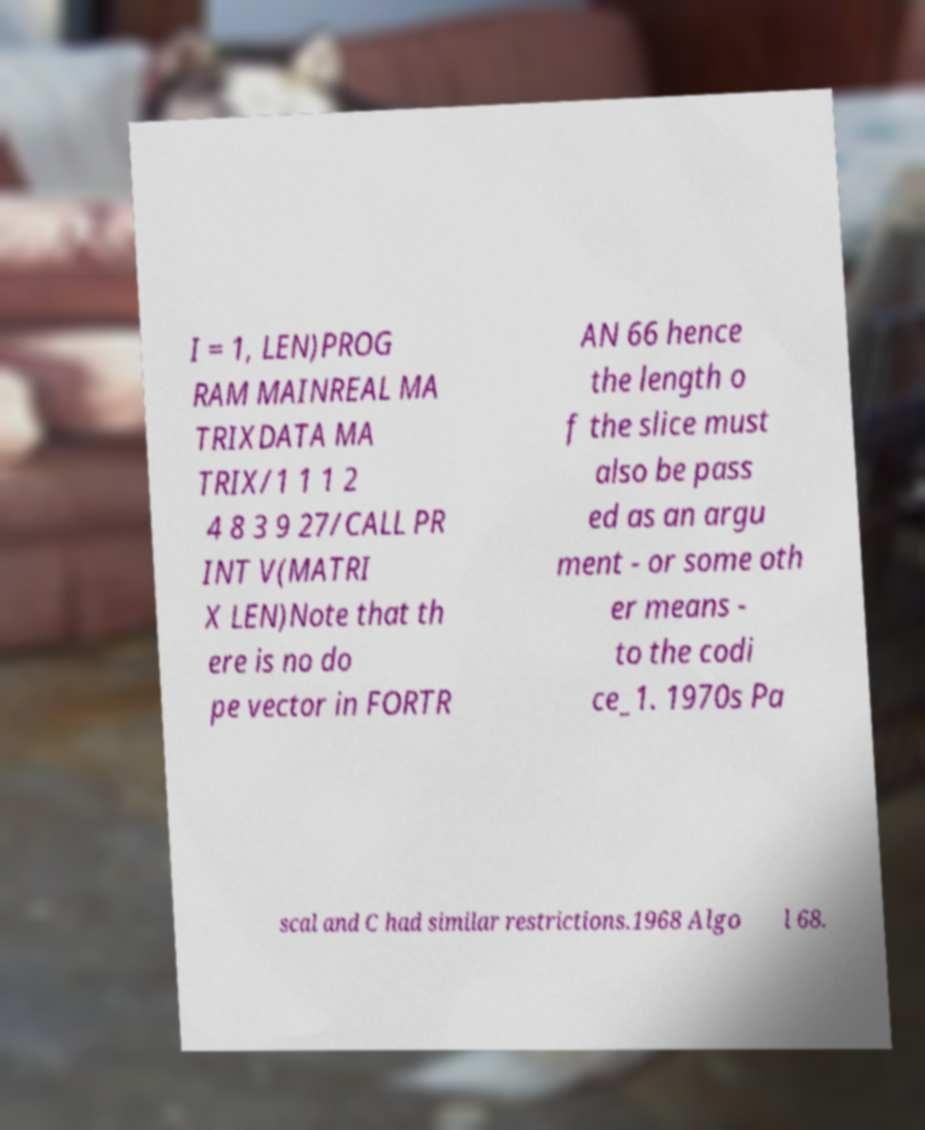Could you extract and type out the text from this image? I = 1, LEN)PROG RAM MAINREAL MA TRIXDATA MA TRIX/1 1 1 2 4 8 3 9 27/CALL PR INT V(MATRI X LEN)Note that th ere is no do pe vector in FORTR AN 66 hence the length o f the slice must also be pass ed as an argu ment - or some oth er means - to the codi ce_1. 1970s Pa scal and C had similar restrictions.1968 Algo l 68. 